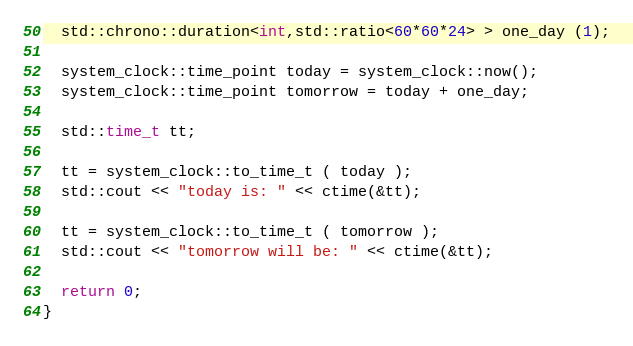Convert code to text. <code><loc_0><loc_0><loc_500><loc_500><_C++_>
  std::chrono::duration<int,std::ratio<60*60*24> > one_day (1);

  system_clock::time_point today = system_clock::now();
  system_clock::time_point tomorrow = today + one_day;

  std::time_t tt;

  tt = system_clock::to_time_t ( today );
  std::cout << "today is: " << ctime(&tt);

  tt = system_clock::to_time_t ( tomorrow );
  std::cout << "tomorrow will be: " << ctime(&tt);

  return 0;
}
</code> 